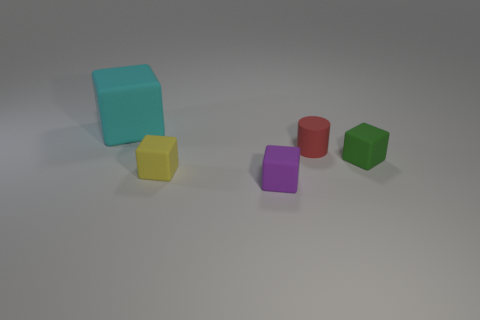Subtract all small purple matte cubes. How many cubes are left? 3 Subtract all yellow cubes. How many cubes are left? 3 Add 2 small yellow metal objects. How many objects exist? 7 Subtract all cubes. How many objects are left? 1 Subtract 1 cylinders. How many cylinders are left? 0 Add 3 purple cylinders. How many purple cylinders exist? 3 Subtract 0 yellow cylinders. How many objects are left? 5 Subtract all gray blocks. Subtract all green balls. How many blocks are left? 4 Subtract all blue things. Subtract all rubber cylinders. How many objects are left? 4 Add 2 cylinders. How many cylinders are left? 3 